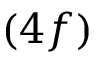Convert formula to latex. <formula><loc_0><loc_0><loc_500><loc_500>( 4 f )</formula> 